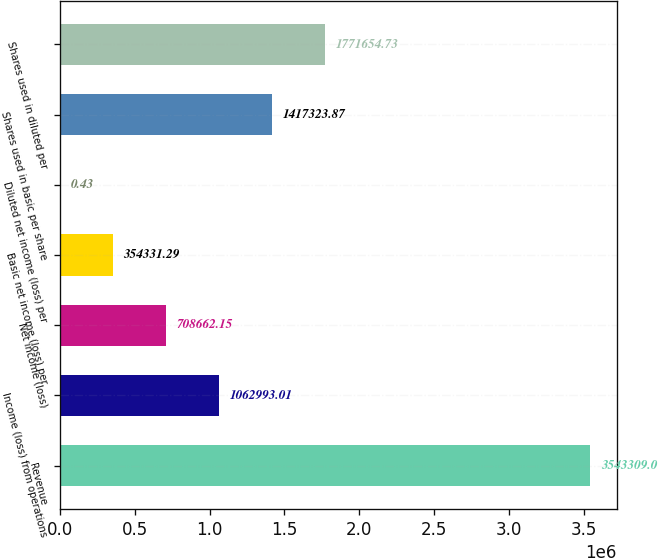<chart> <loc_0><loc_0><loc_500><loc_500><bar_chart><fcel>Revenue<fcel>Income (loss) from operations<fcel>Net income (loss)<fcel>Basic net income (loss) per<fcel>Diluted net income (loss) per<fcel>Shares used in basic per share<fcel>Shares used in diluted per<nl><fcel>3.54331e+06<fcel>1.06299e+06<fcel>708662<fcel>354331<fcel>0.43<fcel>1.41732e+06<fcel>1.77165e+06<nl></chart> 